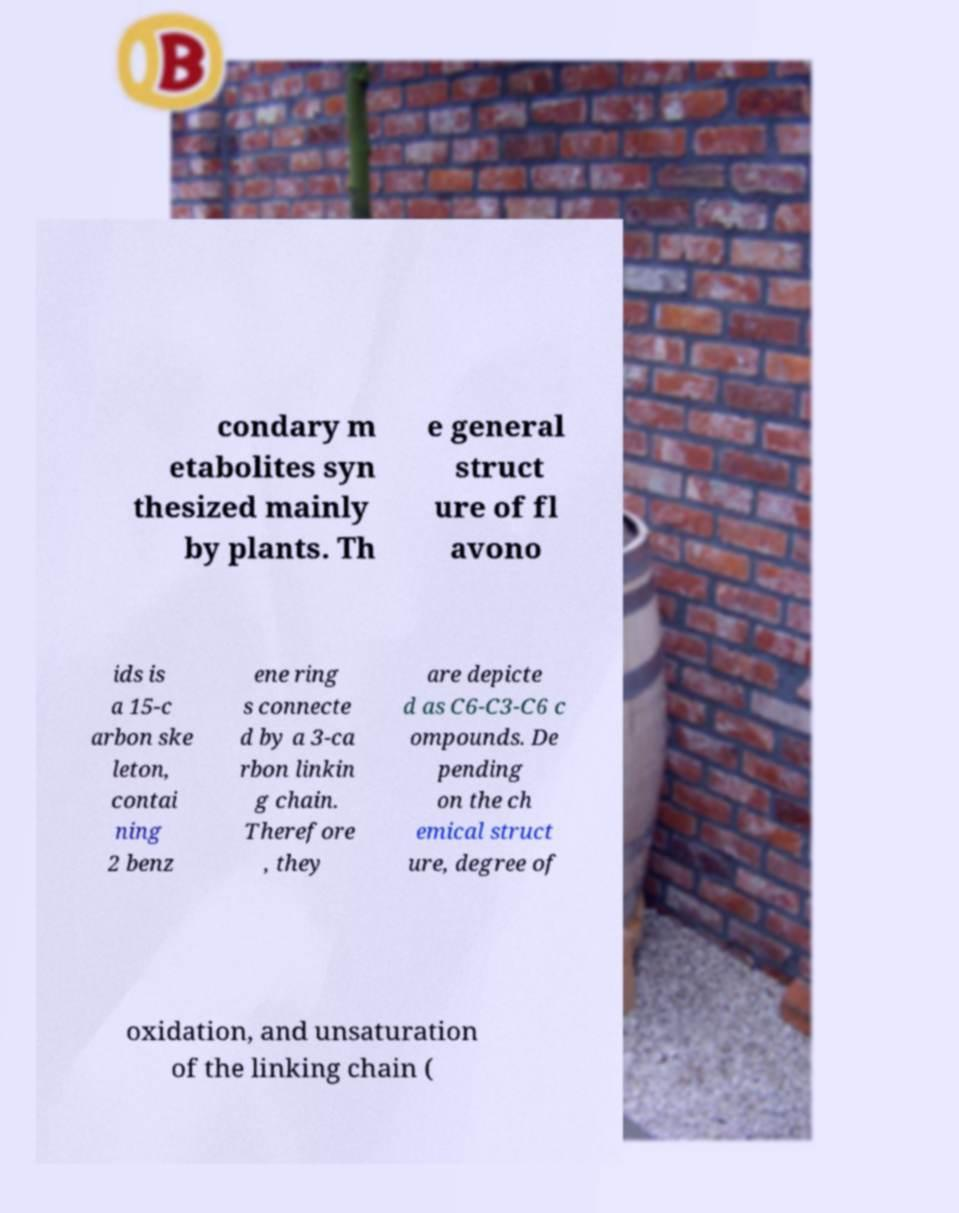There's text embedded in this image that I need extracted. Can you transcribe it verbatim? condary m etabolites syn thesized mainly by plants. Th e general struct ure of fl avono ids is a 15-c arbon ske leton, contai ning 2 benz ene ring s connecte d by a 3-ca rbon linkin g chain. Therefore , they are depicte d as C6-C3-C6 c ompounds. De pending on the ch emical struct ure, degree of oxidation, and unsaturation of the linking chain ( 